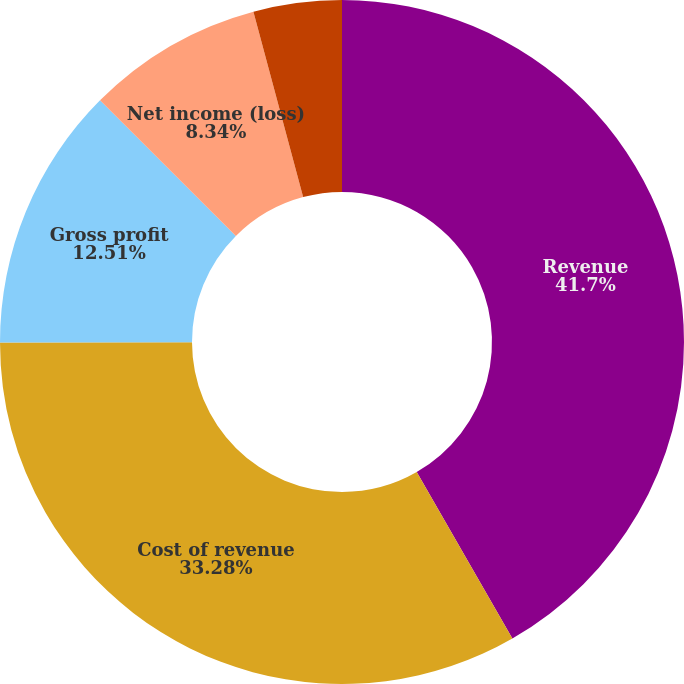<chart> <loc_0><loc_0><loc_500><loc_500><pie_chart><fcel>Revenue<fcel>Cost of revenue<fcel>Gross profit<fcel>Net income (loss)<fcel>Basic net income (loss) per<fcel>Diluted net income (loss) per<nl><fcel>41.7%<fcel>33.28%<fcel>12.51%<fcel>8.34%<fcel>0.0%<fcel>4.17%<nl></chart> 